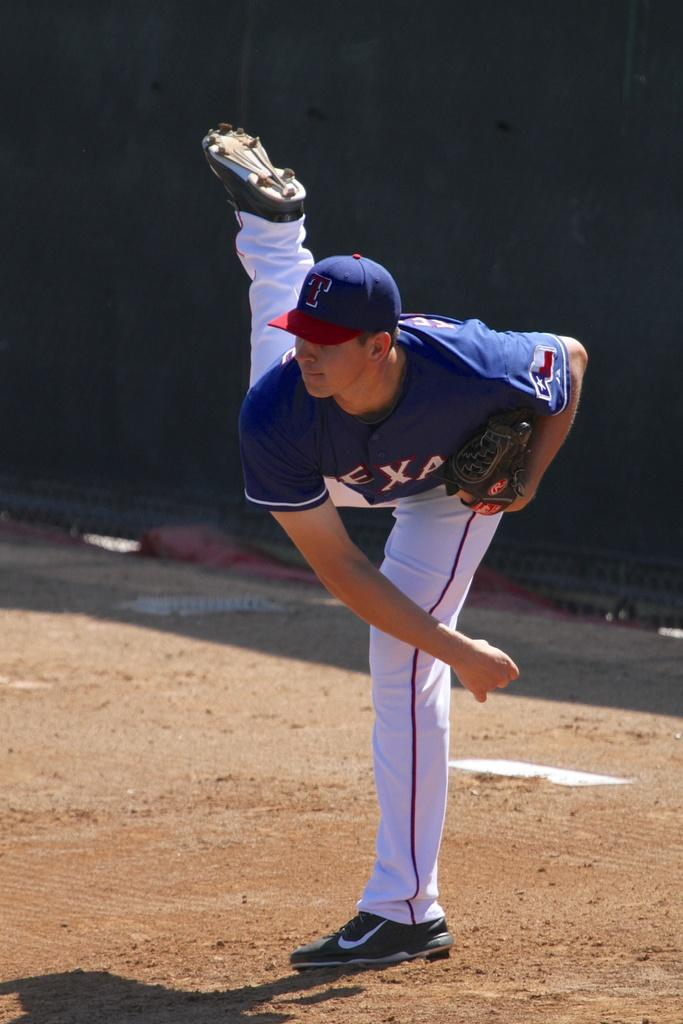Provide a one-sentence caption for the provided image. a man in a jersey with letters EXA just finished throwing a ball. 